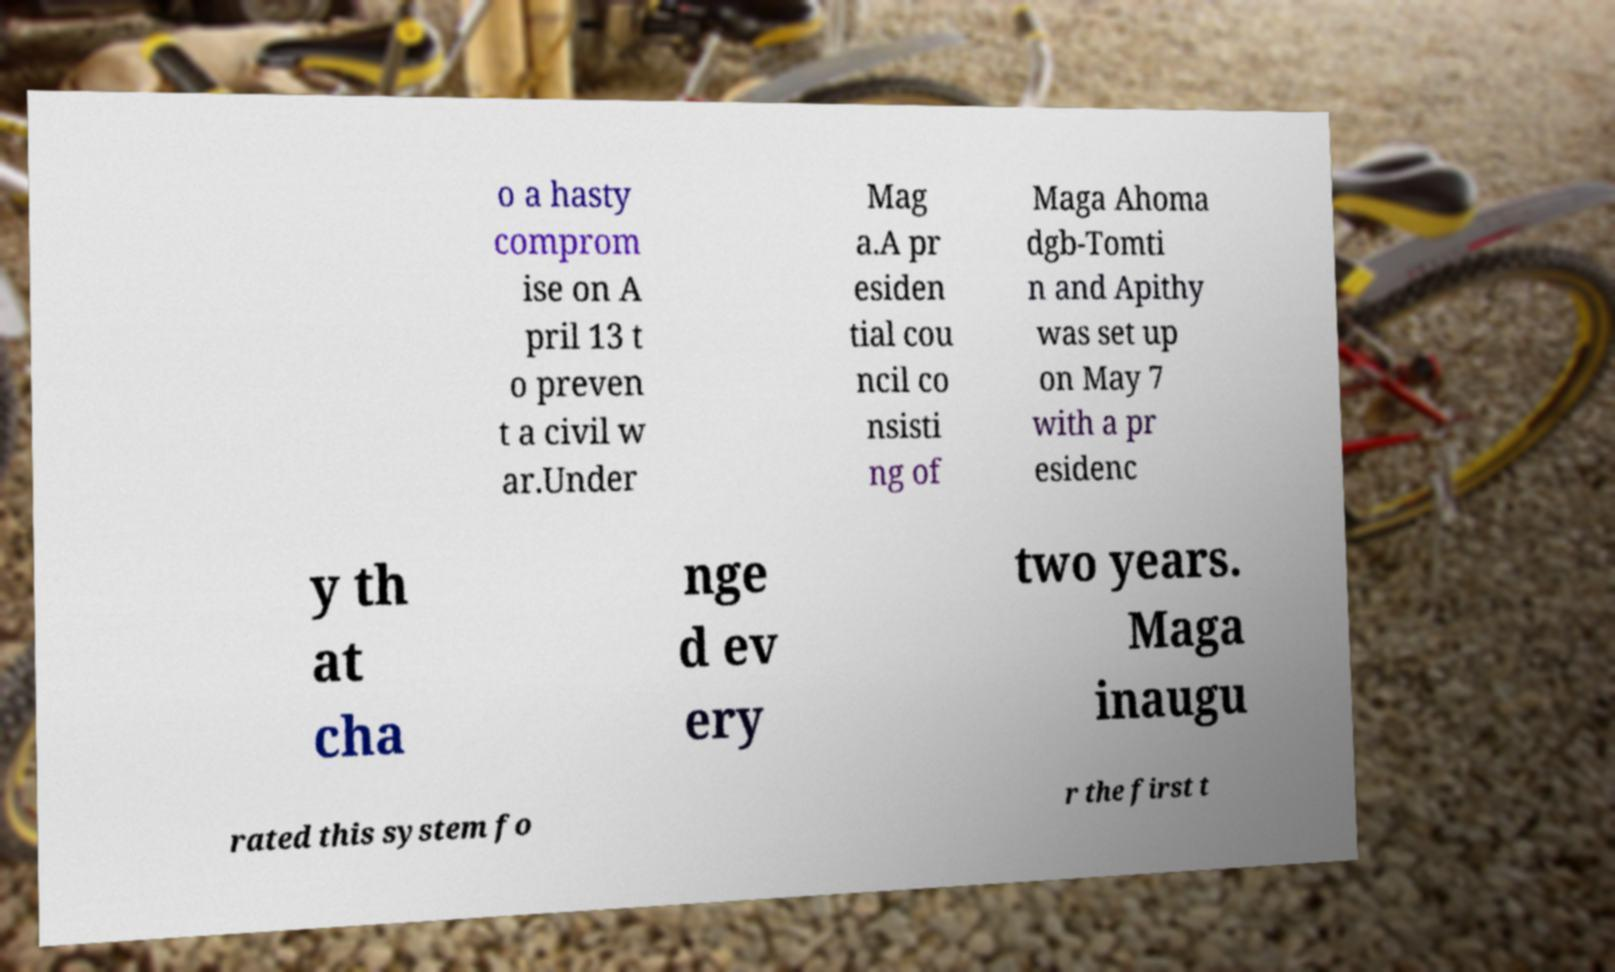What messages or text are displayed in this image? I need them in a readable, typed format. o a hasty comprom ise on A pril 13 t o preven t a civil w ar.Under Mag a.A pr esiden tial cou ncil co nsisti ng of Maga Ahoma dgb-Tomti n and Apithy was set up on May 7 with a pr esidenc y th at cha nge d ev ery two years. Maga inaugu rated this system fo r the first t 